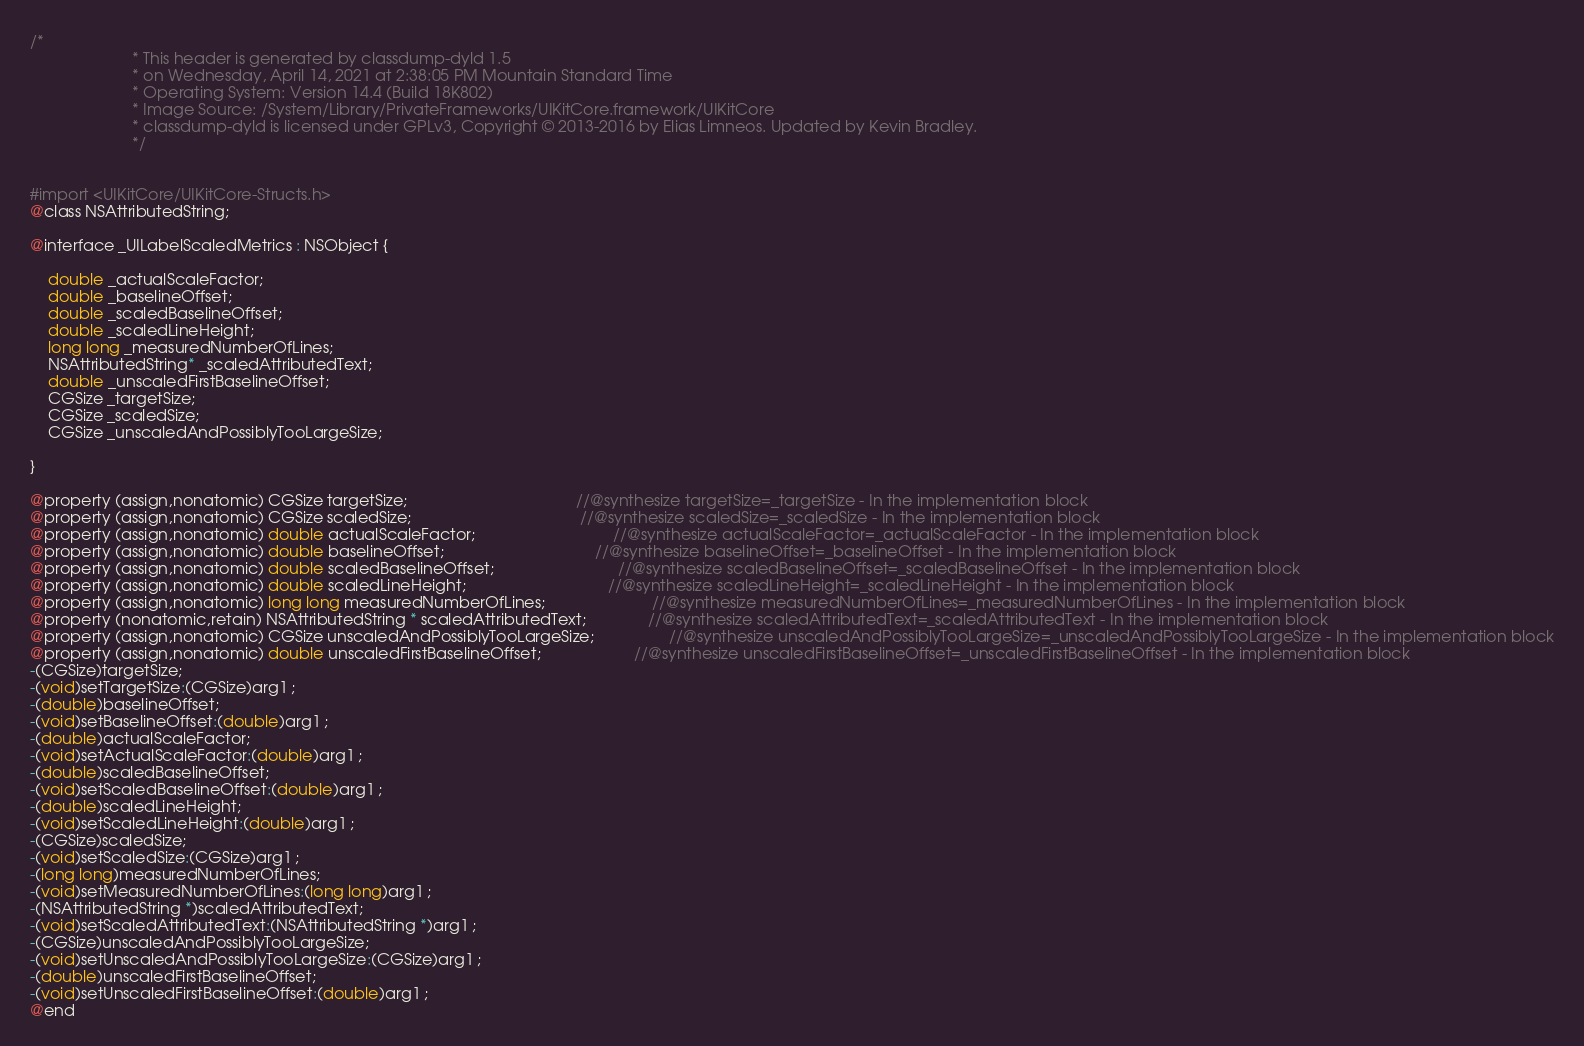<code> <loc_0><loc_0><loc_500><loc_500><_C_>/*
                       * This header is generated by classdump-dyld 1.5
                       * on Wednesday, April 14, 2021 at 2:38:05 PM Mountain Standard Time
                       * Operating System: Version 14.4 (Build 18K802)
                       * Image Source: /System/Library/PrivateFrameworks/UIKitCore.framework/UIKitCore
                       * classdump-dyld is licensed under GPLv3, Copyright © 2013-2016 by Elias Limneos. Updated by Kevin Bradley.
                       */


#import <UIKitCore/UIKitCore-Structs.h>
@class NSAttributedString;

@interface _UILabelScaledMetrics : NSObject {

	double _actualScaleFactor;
	double _baselineOffset;
	double _scaledBaselineOffset;
	double _scaledLineHeight;
	long long _measuredNumberOfLines;
	NSAttributedString* _scaledAttributedText;
	double _unscaledFirstBaselineOffset;
	CGSize _targetSize;
	CGSize _scaledSize;
	CGSize _unscaledAndPossiblyTooLargeSize;

}

@property (assign,nonatomic) CGSize targetSize;                                      //@synthesize targetSize=_targetSize - In the implementation block
@property (assign,nonatomic) CGSize scaledSize;                                      //@synthesize scaledSize=_scaledSize - In the implementation block
@property (assign,nonatomic) double actualScaleFactor;                               //@synthesize actualScaleFactor=_actualScaleFactor - In the implementation block
@property (assign,nonatomic) double baselineOffset;                                  //@synthesize baselineOffset=_baselineOffset - In the implementation block
@property (assign,nonatomic) double scaledBaselineOffset;                            //@synthesize scaledBaselineOffset=_scaledBaselineOffset - In the implementation block
@property (assign,nonatomic) double scaledLineHeight;                                //@synthesize scaledLineHeight=_scaledLineHeight - In the implementation block
@property (assign,nonatomic) long long measuredNumberOfLines;                        //@synthesize measuredNumberOfLines=_measuredNumberOfLines - In the implementation block
@property (nonatomic,retain) NSAttributedString * scaledAttributedText;              //@synthesize scaledAttributedText=_scaledAttributedText - In the implementation block
@property (assign,nonatomic) CGSize unscaledAndPossiblyTooLargeSize;                 //@synthesize unscaledAndPossiblyTooLargeSize=_unscaledAndPossiblyTooLargeSize - In the implementation block
@property (assign,nonatomic) double unscaledFirstBaselineOffset;                     //@synthesize unscaledFirstBaselineOffset=_unscaledFirstBaselineOffset - In the implementation block
-(CGSize)targetSize;
-(void)setTargetSize:(CGSize)arg1 ;
-(double)baselineOffset;
-(void)setBaselineOffset:(double)arg1 ;
-(double)actualScaleFactor;
-(void)setActualScaleFactor:(double)arg1 ;
-(double)scaledBaselineOffset;
-(void)setScaledBaselineOffset:(double)arg1 ;
-(double)scaledLineHeight;
-(void)setScaledLineHeight:(double)arg1 ;
-(CGSize)scaledSize;
-(void)setScaledSize:(CGSize)arg1 ;
-(long long)measuredNumberOfLines;
-(void)setMeasuredNumberOfLines:(long long)arg1 ;
-(NSAttributedString *)scaledAttributedText;
-(void)setScaledAttributedText:(NSAttributedString *)arg1 ;
-(CGSize)unscaledAndPossiblyTooLargeSize;
-(void)setUnscaledAndPossiblyTooLargeSize:(CGSize)arg1 ;
-(double)unscaledFirstBaselineOffset;
-(void)setUnscaledFirstBaselineOffset:(double)arg1 ;
@end

</code> 